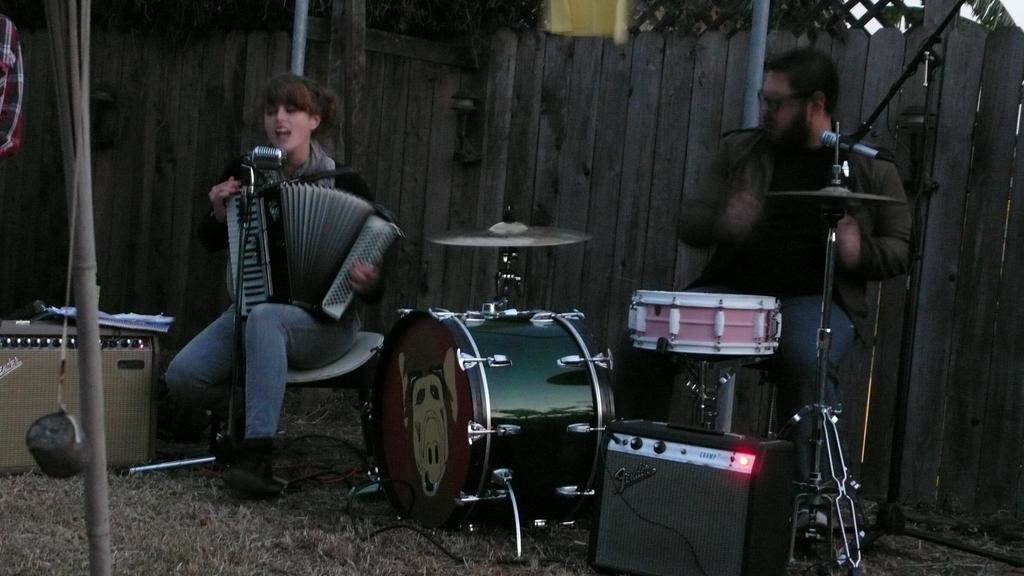How many people are in the image? There are two persons in the image. What are the persons doing in the image? The persons are playing musical instruments. What can be seen in the background of the image? There is a wall in the background of the image. Are there any musical instruments on the ground in the image? Yes, there are musical instruments placed on the ground in the image. What type of club can be seen in the hands of the persons in the image? There are no clubs visible in the hands of the persons in the image; they are playing musical instruments. 